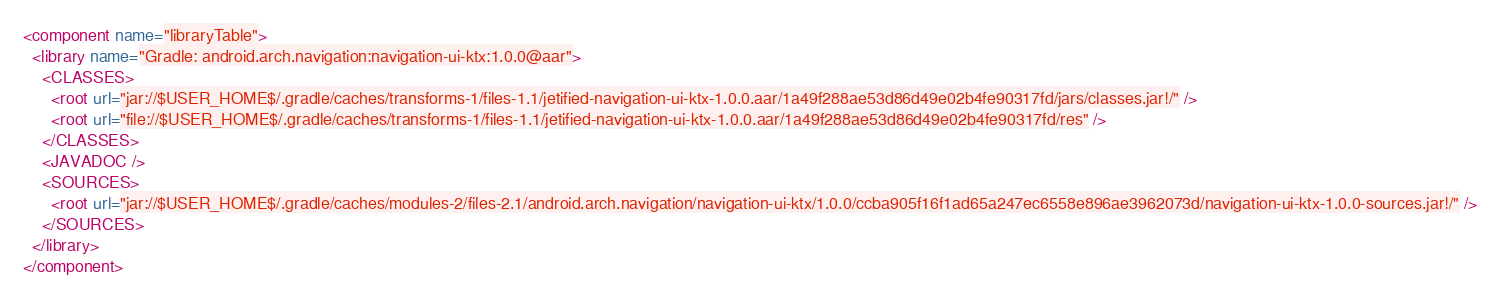Convert code to text. <code><loc_0><loc_0><loc_500><loc_500><_XML_><component name="libraryTable">
  <library name="Gradle: android.arch.navigation:navigation-ui-ktx:1.0.0@aar">
    <CLASSES>
      <root url="jar://$USER_HOME$/.gradle/caches/transforms-1/files-1.1/jetified-navigation-ui-ktx-1.0.0.aar/1a49f288ae53d86d49e02b4fe90317fd/jars/classes.jar!/" />
      <root url="file://$USER_HOME$/.gradle/caches/transforms-1/files-1.1/jetified-navigation-ui-ktx-1.0.0.aar/1a49f288ae53d86d49e02b4fe90317fd/res" />
    </CLASSES>
    <JAVADOC />
    <SOURCES>
      <root url="jar://$USER_HOME$/.gradle/caches/modules-2/files-2.1/android.arch.navigation/navigation-ui-ktx/1.0.0/ccba905f16f1ad65a247ec6558e896ae3962073d/navigation-ui-ktx-1.0.0-sources.jar!/" />
    </SOURCES>
  </library>
</component></code> 